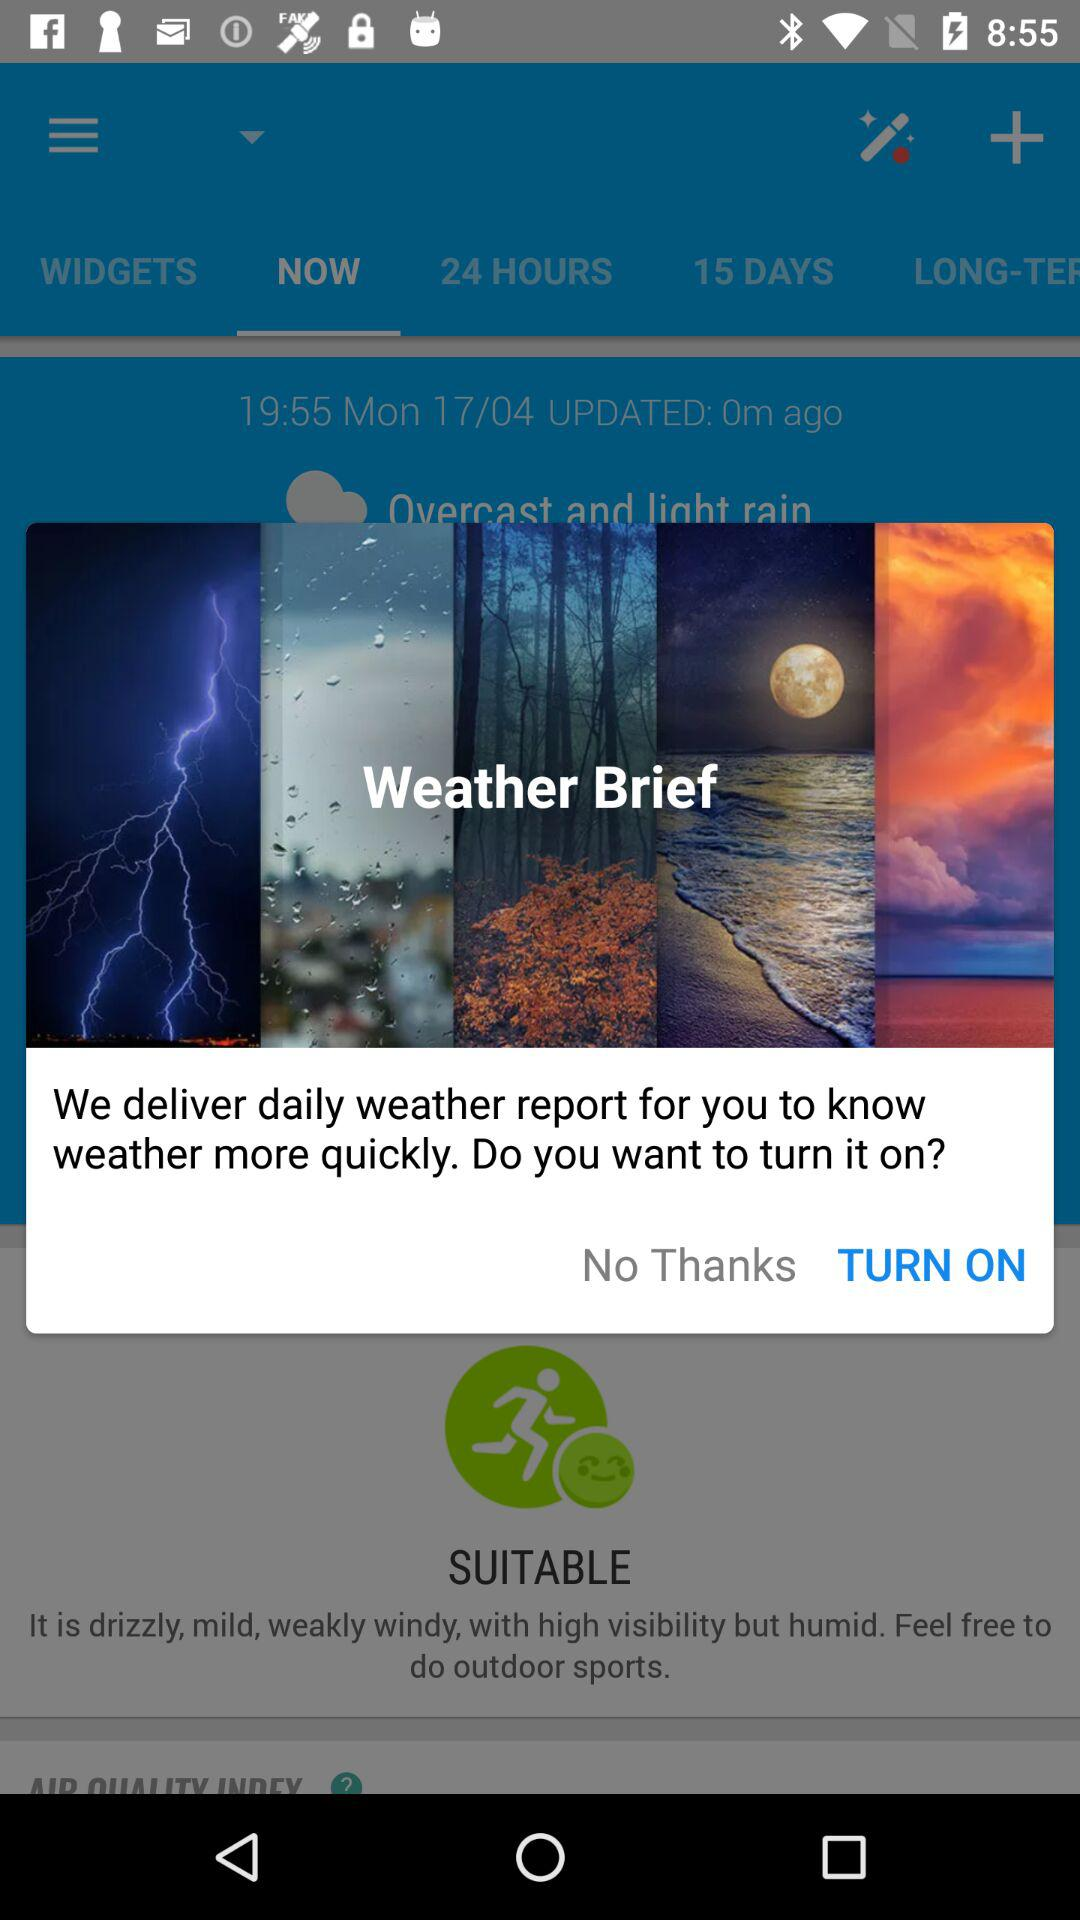What is the app name?
When the provided information is insufficient, respond with <no answer>. <no answer> 